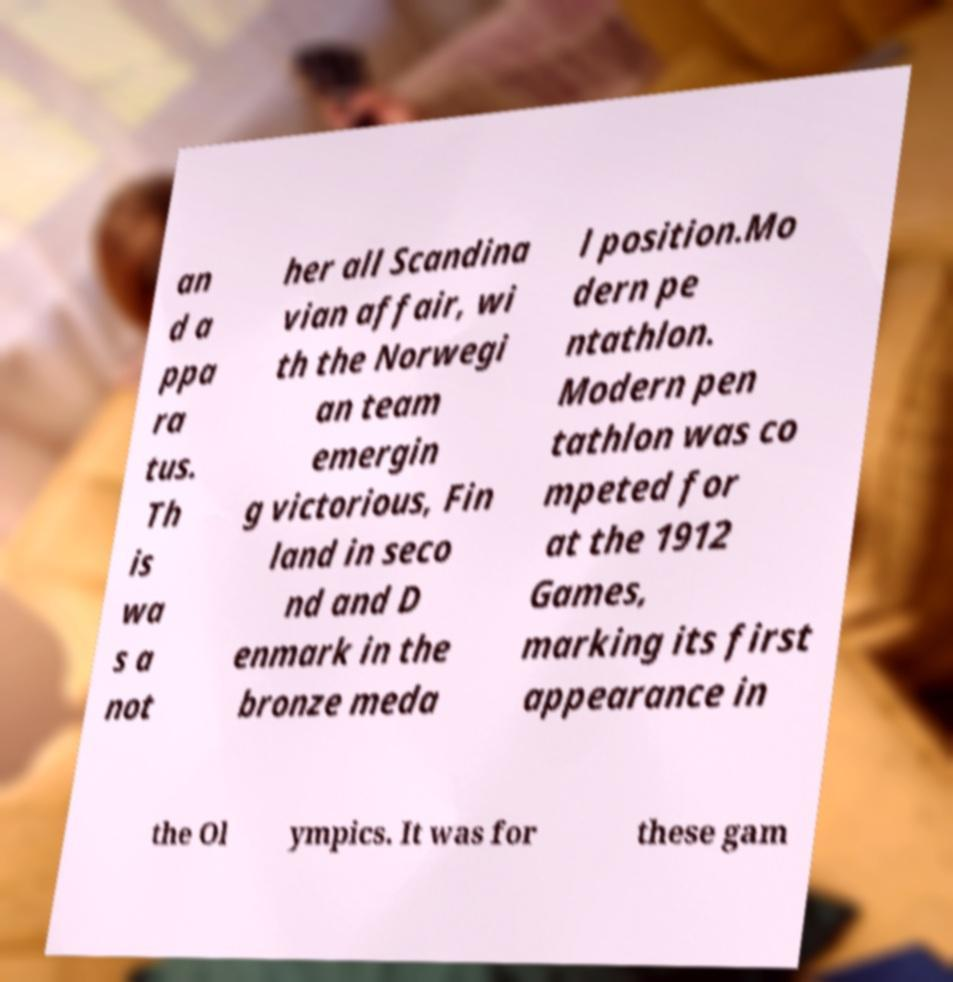Please identify and transcribe the text found in this image. an d a ppa ra tus. Th is wa s a not her all Scandina vian affair, wi th the Norwegi an team emergin g victorious, Fin land in seco nd and D enmark in the bronze meda l position.Mo dern pe ntathlon. Modern pen tathlon was co mpeted for at the 1912 Games, marking its first appearance in the Ol ympics. It was for these gam 